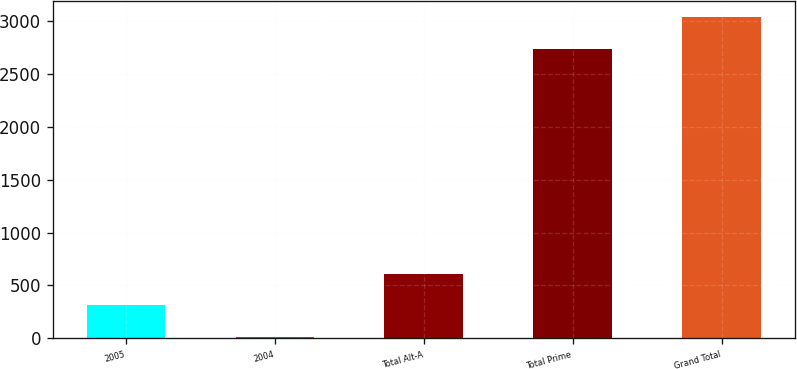<chart> <loc_0><loc_0><loc_500><loc_500><bar_chart><fcel>2005<fcel>2004<fcel>Total Alt-A<fcel>Total Prime<fcel>Grand Total<nl><fcel>311.3<fcel>10<fcel>612.6<fcel>2736<fcel>3037.3<nl></chart> 